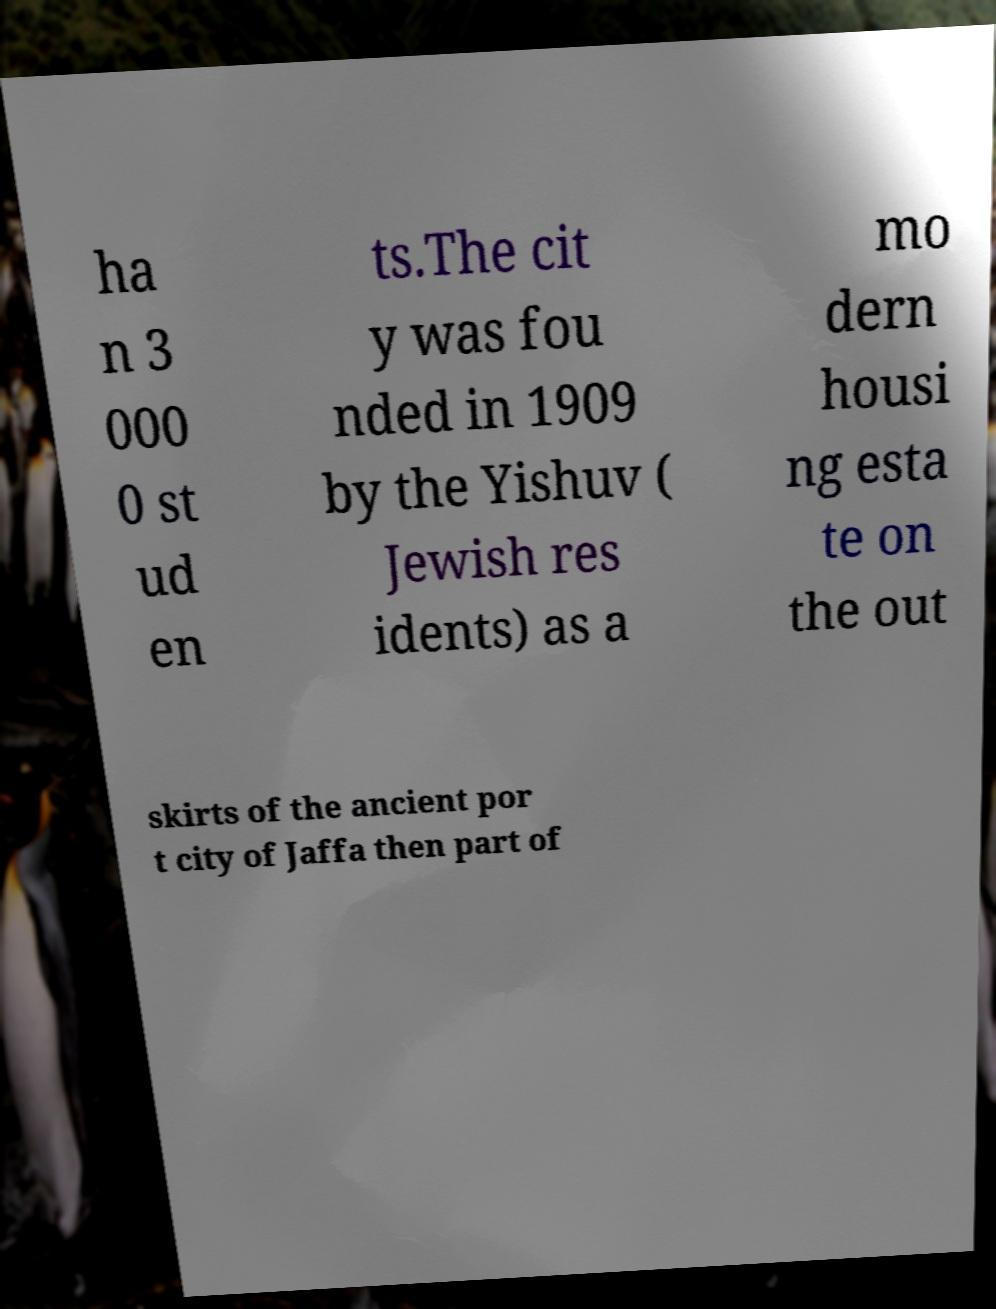For documentation purposes, I need the text within this image transcribed. Could you provide that? ha n 3 000 0 st ud en ts.The cit y was fou nded in 1909 by the Yishuv ( Jewish res idents) as a mo dern housi ng esta te on the out skirts of the ancient por t city of Jaffa then part of 